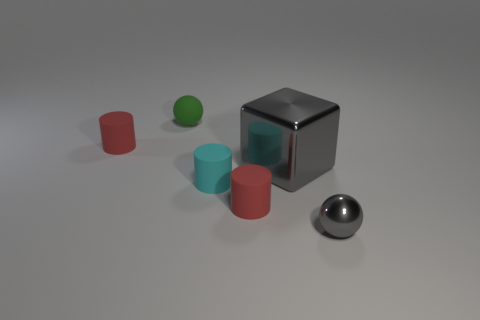What shape is the thing that is the same color as the large metallic cube?
Make the answer very short. Sphere. There is a sphere that is the same color as the large thing; what is its size?
Offer a terse response. Small. Is there another gray shiny object of the same shape as the tiny gray object?
Your answer should be compact. No. What color is the shiny ball that is the same size as the cyan rubber cylinder?
Your response must be concise. Gray. Is the number of tiny rubber things right of the tiny gray thing less than the number of tiny red things that are on the right side of the tiny green rubber sphere?
Your answer should be compact. Yes. There is a rubber cylinder right of the cyan rubber thing; is its size the same as the big gray cube?
Ensure brevity in your answer.  No. What is the shape of the small red matte thing behind the big gray cube?
Provide a short and direct response. Cylinder. Is the number of small gray rubber things greater than the number of big metallic objects?
Provide a short and direct response. No. There is a thing that is to the left of the small green object; is its color the same as the large shiny thing?
Make the answer very short. No. What number of things are balls on the right side of the big gray metallic object or small spheres on the right side of the small cyan rubber thing?
Your answer should be compact. 1. 